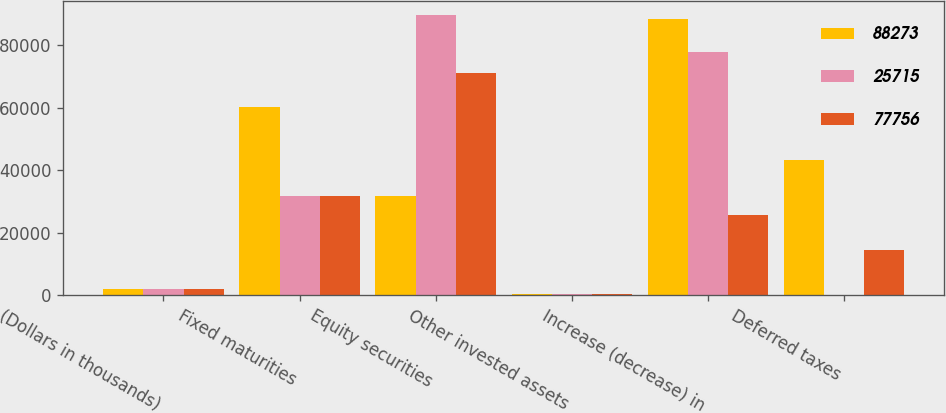<chart> <loc_0><loc_0><loc_500><loc_500><stacked_bar_chart><ecel><fcel>(Dollars in thousands)<fcel>Fixed maturities<fcel>Equity securities<fcel>Other invested assets<fcel>Increase (decrease) in<fcel>Deferred taxes<nl><fcel>88273<fcel>2006<fcel>60210<fcel>31608<fcel>466<fcel>88273<fcel>43399<nl><fcel>25715<fcel>2005<fcel>31608<fcel>89582<fcel>291<fcel>77756<fcel>31<nl><fcel>77756<fcel>2004<fcel>31608<fcel>71179<fcel>520<fcel>25715<fcel>14376<nl></chart> 